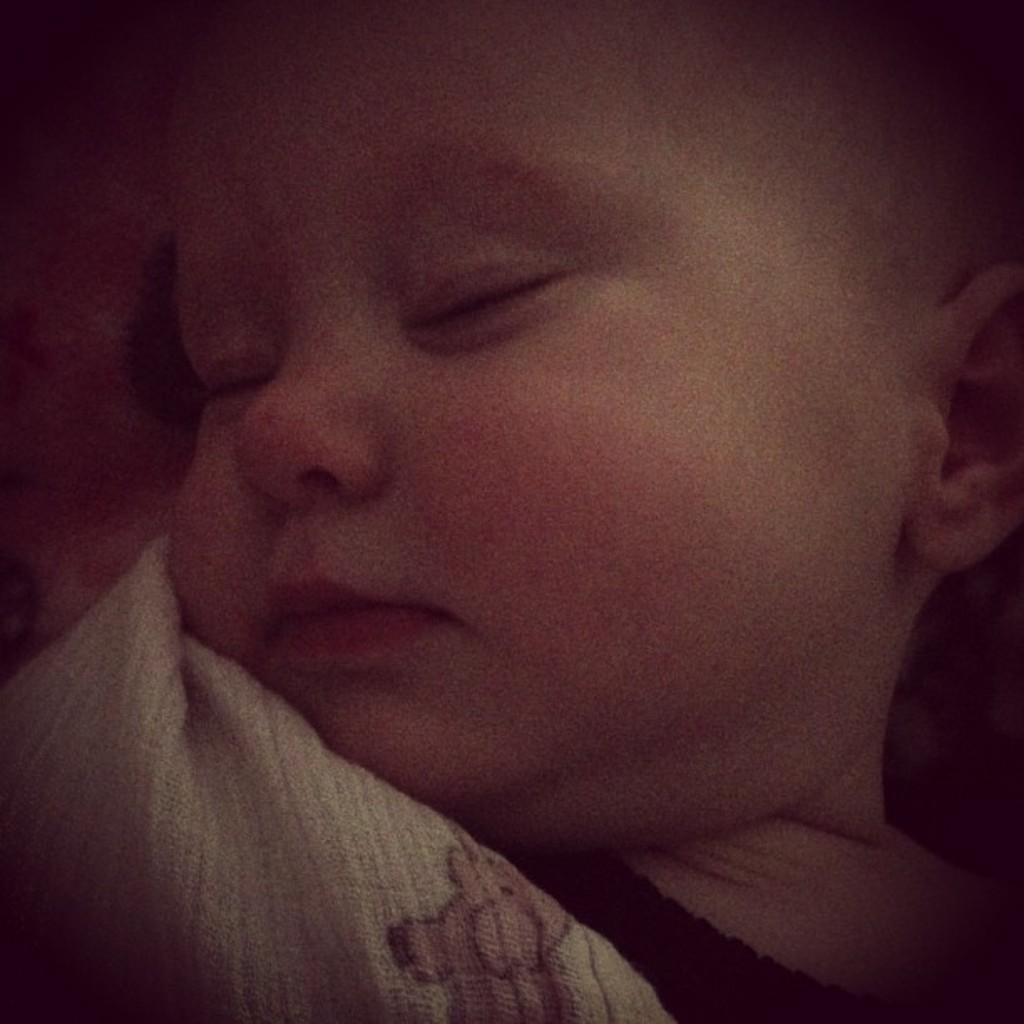What is the main subject of the image? The main subject of the image is a child. What is the child doing in the image? The child is sleeping. What type of lumber is the child using to build a fort in the image? There is no lumber present in the image, and the child is sleeping, not building a fort. How does the child perform an attack on the skateboarder in the image? There is no skateboarder or attack present in the image; the child is sleeping. 